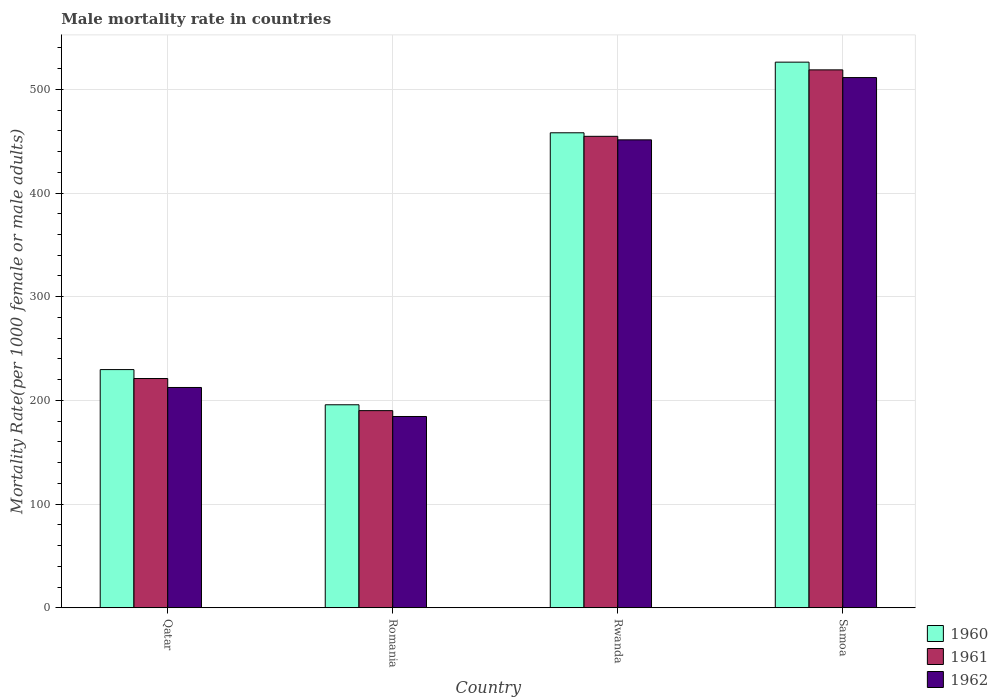How many different coloured bars are there?
Provide a short and direct response. 3. How many groups of bars are there?
Provide a short and direct response. 4. Are the number of bars per tick equal to the number of legend labels?
Provide a short and direct response. Yes. What is the label of the 1st group of bars from the left?
Give a very brief answer. Qatar. In how many cases, is the number of bars for a given country not equal to the number of legend labels?
Make the answer very short. 0. What is the male mortality rate in 1962 in Romania?
Your answer should be compact. 184.47. Across all countries, what is the maximum male mortality rate in 1961?
Offer a terse response. 518.79. Across all countries, what is the minimum male mortality rate in 1960?
Provide a short and direct response. 195.77. In which country was the male mortality rate in 1961 maximum?
Provide a succinct answer. Samoa. In which country was the male mortality rate in 1962 minimum?
Your response must be concise. Romania. What is the total male mortality rate in 1960 in the graph?
Ensure brevity in your answer.  1409.79. What is the difference between the male mortality rate in 1961 in Qatar and that in Romania?
Provide a succinct answer. 30.97. What is the difference between the male mortality rate in 1960 in Qatar and the male mortality rate in 1962 in Romania?
Your answer should be compact. 45.24. What is the average male mortality rate in 1960 per country?
Provide a succinct answer. 352.45. What is the difference between the male mortality rate of/in 1960 and male mortality rate of/in 1961 in Qatar?
Provide a succinct answer. 8.62. In how many countries, is the male mortality rate in 1960 greater than 280?
Ensure brevity in your answer.  2. What is the ratio of the male mortality rate in 1961 in Rwanda to that in Samoa?
Ensure brevity in your answer.  0.88. Is the male mortality rate in 1960 in Qatar less than that in Samoa?
Your answer should be very brief. Yes. What is the difference between the highest and the second highest male mortality rate in 1961?
Offer a very short reply. -233.61. What is the difference between the highest and the lowest male mortality rate in 1962?
Provide a succinct answer. 326.88. In how many countries, is the male mortality rate in 1962 greater than the average male mortality rate in 1962 taken over all countries?
Your response must be concise. 2. Is the sum of the male mortality rate in 1960 in Rwanda and Samoa greater than the maximum male mortality rate in 1962 across all countries?
Your response must be concise. Yes. What does the 2nd bar from the left in Samoa represents?
Provide a short and direct response. 1961. What does the 2nd bar from the right in Rwanda represents?
Ensure brevity in your answer.  1961. Is it the case that in every country, the sum of the male mortality rate in 1961 and male mortality rate in 1962 is greater than the male mortality rate in 1960?
Offer a very short reply. Yes. How many countries are there in the graph?
Offer a very short reply. 4. What is the difference between two consecutive major ticks on the Y-axis?
Keep it short and to the point. 100. Are the values on the major ticks of Y-axis written in scientific E-notation?
Make the answer very short. No. Where does the legend appear in the graph?
Offer a terse response. Bottom right. How many legend labels are there?
Give a very brief answer. 3. How are the legend labels stacked?
Keep it short and to the point. Vertical. What is the title of the graph?
Your answer should be very brief. Male mortality rate in countries. Does "1976" appear as one of the legend labels in the graph?
Make the answer very short. No. What is the label or title of the X-axis?
Your response must be concise. Country. What is the label or title of the Y-axis?
Provide a short and direct response. Mortality Rate(per 1000 female or male adults). What is the Mortality Rate(per 1000 female or male adults) of 1960 in Qatar?
Make the answer very short. 229.71. What is the Mortality Rate(per 1000 female or male adults) in 1961 in Qatar?
Give a very brief answer. 221.08. What is the Mortality Rate(per 1000 female or male adults) of 1962 in Qatar?
Offer a terse response. 212.46. What is the Mortality Rate(per 1000 female or male adults) in 1960 in Romania?
Give a very brief answer. 195.77. What is the Mortality Rate(per 1000 female or male adults) in 1961 in Romania?
Offer a very short reply. 190.12. What is the Mortality Rate(per 1000 female or male adults) in 1962 in Romania?
Your answer should be compact. 184.47. What is the Mortality Rate(per 1000 female or male adults) in 1960 in Rwanda?
Keep it short and to the point. 458.1. What is the Mortality Rate(per 1000 female or male adults) of 1961 in Rwanda?
Offer a terse response. 454.69. What is the Mortality Rate(per 1000 female or male adults) of 1962 in Rwanda?
Make the answer very short. 451.29. What is the Mortality Rate(per 1000 female or male adults) of 1960 in Samoa?
Offer a terse response. 526.23. What is the Mortality Rate(per 1000 female or male adults) of 1961 in Samoa?
Ensure brevity in your answer.  518.79. What is the Mortality Rate(per 1000 female or male adults) of 1962 in Samoa?
Provide a short and direct response. 511.35. Across all countries, what is the maximum Mortality Rate(per 1000 female or male adults) in 1960?
Keep it short and to the point. 526.23. Across all countries, what is the maximum Mortality Rate(per 1000 female or male adults) in 1961?
Offer a very short reply. 518.79. Across all countries, what is the maximum Mortality Rate(per 1000 female or male adults) in 1962?
Your response must be concise. 511.35. Across all countries, what is the minimum Mortality Rate(per 1000 female or male adults) of 1960?
Offer a very short reply. 195.77. Across all countries, what is the minimum Mortality Rate(per 1000 female or male adults) of 1961?
Offer a terse response. 190.12. Across all countries, what is the minimum Mortality Rate(per 1000 female or male adults) in 1962?
Offer a very short reply. 184.47. What is the total Mortality Rate(per 1000 female or male adults) in 1960 in the graph?
Offer a very short reply. 1409.79. What is the total Mortality Rate(per 1000 female or male adults) in 1961 in the graph?
Keep it short and to the point. 1384.68. What is the total Mortality Rate(per 1000 female or male adults) of 1962 in the graph?
Your answer should be very brief. 1359.57. What is the difference between the Mortality Rate(per 1000 female or male adults) of 1960 in Qatar and that in Romania?
Provide a short and direct response. 33.94. What is the difference between the Mortality Rate(per 1000 female or male adults) of 1961 in Qatar and that in Romania?
Ensure brevity in your answer.  30.97. What is the difference between the Mortality Rate(per 1000 female or male adults) of 1962 in Qatar and that in Romania?
Your response must be concise. 27.99. What is the difference between the Mortality Rate(per 1000 female or male adults) in 1960 in Qatar and that in Rwanda?
Make the answer very short. -228.39. What is the difference between the Mortality Rate(per 1000 female or male adults) in 1961 in Qatar and that in Rwanda?
Your answer should be very brief. -233.61. What is the difference between the Mortality Rate(per 1000 female or male adults) of 1962 in Qatar and that in Rwanda?
Ensure brevity in your answer.  -238.83. What is the difference between the Mortality Rate(per 1000 female or male adults) of 1960 in Qatar and that in Samoa?
Offer a very short reply. -296.52. What is the difference between the Mortality Rate(per 1000 female or male adults) of 1961 in Qatar and that in Samoa?
Your answer should be compact. -297.71. What is the difference between the Mortality Rate(per 1000 female or male adults) of 1962 in Qatar and that in Samoa?
Your answer should be compact. -298.89. What is the difference between the Mortality Rate(per 1000 female or male adults) of 1960 in Romania and that in Rwanda?
Make the answer very short. -262.33. What is the difference between the Mortality Rate(per 1000 female or male adults) of 1961 in Romania and that in Rwanda?
Provide a short and direct response. -264.57. What is the difference between the Mortality Rate(per 1000 female or male adults) in 1962 in Romania and that in Rwanda?
Your answer should be very brief. -266.82. What is the difference between the Mortality Rate(per 1000 female or male adults) of 1960 in Romania and that in Samoa?
Your response must be concise. -330.46. What is the difference between the Mortality Rate(per 1000 female or male adults) of 1961 in Romania and that in Samoa?
Make the answer very short. -328.67. What is the difference between the Mortality Rate(per 1000 female or male adults) of 1962 in Romania and that in Samoa?
Keep it short and to the point. -326.88. What is the difference between the Mortality Rate(per 1000 female or male adults) in 1960 in Rwanda and that in Samoa?
Keep it short and to the point. -68.13. What is the difference between the Mortality Rate(per 1000 female or male adults) of 1961 in Rwanda and that in Samoa?
Offer a terse response. -64.1. What is the difference between the Mortality Rate(per 1000 female or male adults) of 1962 in Rwanda and that in Samoa?
Your answer should be very brief. -60.07. What is the difference between the Mortality Rate(per 1000 female or male adults) in 1960 in Qatar and the Mortality Rate(per 1000 female or male adults) in 1961 in Romania?
Provide a short and direct response. 39.59. What is the difference between the Mortality Rate(per 1000 female or male adults) of 1960 in Qatar and the Mortality Rate(per 1000 female or male adults) of 1962 in Romania?
Your answer should be very brief. 45.24. What is the difference between the Mortality Rate(per 1000 female or male adults) in 1961 in Qatar and the Mortality Rate(per 1000 female or male adults) in 1962 in Romania?
Give a very brief answer. 36.61. What is the difference between the Mortality Rate(per 1000 female or male adults) in 1960 in Qatar and the Mortality Rate(per 1000 female or male adults) in 1961 in Rwanda?
Provide a succinct answer. -224.99. What is the difference between the Mortality Rate(per 1000 female or male adults) of 1960 in Qatar and the Mortality Rate(per 1000 female or male adults) of 1962 in Rwanda?
Your response must be concise. -221.58. What is the difference between the Mortality Rate(per 1000 female or male adults) of 1961 in Qatar and the Mortality Rate(per 1000 female or male adults) of 1962 in Rwanda?
Make the answer very short. -230.21. What is the difference between the Mortality Rate(per 1000 female or male adults) in 1960 in Qatar and the Mortality Rate(per 1000 female or male adults) in 1961 in Samoa?
Give a very brief answer. -289.08. What is the difference between the Mortality Rate(per 1000 female or male adults) in 1960 in Qatar and the Mortality Rate(per 1000 female or male adults) in 1962 in Samoa?
Provide a short and direct response. -281.65. What is the difference between the Mortality Rate(per 1000 female or male adults) in 1961 in Qatar and the Mortality Rate(per 1000 female or male adults) in 1962 in Samoa?
Provide a succinct answer. -290.27. What is the difference between the Mortality Rate(per 1000 female or male adults) in 1960 in Romania and the Mortality Rate(per 1000 female or male adults) in 1961 in Rwanda?
Provide a succinct answer. -258.93. What is the difference between the Mortality Rate(per 1000 female or male adults) in 1960 in Romania and the Mortality Rate(per 1000 female or male adults) in 1962 in Rwanda?
Your answer should be very brief. -255.52. What is the difference between the Mortality Rate(per 1000 female or male adults) of 1961 in Romania and the Mortality Rate(per 1000 female or male adults) of 1962 in Rwanda?
Make the answer very short. -261.17. What is the difference between the Mortality Rate(per 1000 female or male adults) of 1960 in Romania and the Mortality Rate(per 1000 female or male adults) of 1961 in Samoa?
Make the answer very short. -323.02. What is the difference between the Mortality Rate(per 1000 female or male adults) of 1960 in Romania and the Mortality Rate(per 1000 female or male adults) of 1962 in Samoa?
Make the answer very short. -315.59. What is the difference between the Mortality Rate(per 1000 female or male adults) in 1961 in Romania and the Mortality Rate(per 1000 female or male adults) in 1962 in Samoa?
Your answer should be compact. -321.24. What is the difference between the Mortality Rate(per 1000 female or male adults) in 1960 in Rwanda and the Mortality Rate(per 1000 female or male adults) in 1961 in Samoa?
Offer a very short reply. -60.69. What is the difference between the Mortality Rate(per 1000 female or male adults) in 1960 in Rwanda and the Mortality Rate(per 1000 female or male adults) in 1962 in Samoa?
Your answer should be very brief. -53.26. What is the difference between the Mortality Rate(per 1000 female or male adults) of 1961 in Rwanda and the Mortality Rate(per 1000 female or male adults) of 1962 in Samoa?
Your response must be concise. -56.66. What is the average Mortality Rate(per 1000 female or male adults) in 1960 per country?
Provide a succinct answer. 352.45. What is the average Mortality Rate(per 1000 female or male adults) of 1961 per country?
Your answer should be very brief. 346.17. What is the average Mortality Rate(per 1000 female or male adults) in 1962 per country?
Offer a terse response. 339.89. What is the difference between the Mortality Rate(per 1000 female or male adults) in 1960 and Mortality Rate(per 1000 female or male adults) in 1961 in Qatar?
Offer a very short reply. 8.62. What is the difference between the Mortality Rate(per 1000 female or male adults) in 1960 and Mortality Rate(per 1000 female or male adults) in 1962 in Qatar?
Keep it short and to the point. 17.25. What is the difference between the Mortality Rate(per 1000 female or male adults) of 1961 and Mortality Rate(per 1000 female or male adults) of 1962 in Qatar?
Offer a terse response. 8.62. What is the difference between the Mortality Rate(per 1000 female or male adults) of 1960 and Mortality Rate(per 1000 female or male adults) of 1961 in Romania?
Your answer should be very brief. 5.65. What is the difference between the Mortality Rate(per 1000 female or male adults) of 1960 and Mortality Rate(per 1000 female or male adults) of 1962 in Romania?
Your answer should be compact. 11.3. What is the difference between the Mortality Rate(per 1000 female or male adults) of 1961 and Mortality Rate(per 1000 female or male adults) of 1962 in Romania?
Offer a terse response. 5.65. What is the difference between the Mortality Rate(per 1000 female or male adults) of 1960 and Mortality Rate(per 1000 female or male adults) of 1961 in Rwanda?
Provide a succinct answer. 3.4. What is the difference between the Mortality Rate(per 1000 female or male adults) of 1960 and Mortality Rate(per 1000 female or male adults) of 1962 in Rwanda?
Make the answer very short. 6.81. What is the difference between the Mortality Rate(per 1000 female or male adults) in 1961 and Mortality Rate(per 1000 female or male adults) in 1962 in Rwanda?
Your answer should be very brief. 3.4. What is the difference between the Mortality Rate(per 1000 female or male adults) in 1960 and Mortality Rate(per 1000 female or male adults) in 1961 in Samoa?
Offer a very short reply. 7.44. What is the difference between the Mortality Rate(per 1000 female or male adults) in 1960 and Mortality Rate(per 1000 female or male adults) in 1962 in Samoa?
Your response must be concise. 14.87. What is the difference between the Mortality Rate(per 1000 female or male adults) in 1961 and Mortality Rate(per 1000 female or male adults) in 1962 in Samoa?
Offer a terse response. 7.43. What is the ratio of the Mortality Rate(per 1000 female or male adults) in 1960 in Qatar to that in Romania?
Give a very brief answer. 1.17. What is the ratio of the Mortality Rate(per 1000 female or male adults) of 1961 in Qatar to that in Romania?
Provide a succinct answer. 1.16. What is the ratio of the Mortality Rate(per 1000 female or male adults) in 1962 in Qatar to that in Romania?
Keep it short and to the point. 1.15. What is the ratio of the Mortality Rate(per 1000 female or male adults) of 1960 in Qatar to that in Rwanda?
Make the answer very short. 0.5. What is the ratio of the Mortality Rate(per 1000 female or male adults) of 1961 in Qatar to that in Rwanda?
Offer a very short reply. 0.49. What is the ratio of the Mortality Rate(per 1000 female or male adults) in 1962 in Qatar to that in Rwanda?
Ensure brevity in your answer.  0.47. What is the ratio of the Mortality Rate(per 1000 female or male adults) of 1960 in Qatar to that in Samoa?
Offer a terse response. 0.44. What is the ratio of the Mortality Rate(per 1000 female or male adults) of 1961 in Qatar to that in Samoa?
Provide a succinct answer. 0.43. What is the ratio of the Mortality Rate(per 1000 female or male adults) in 1962 in Qatar to that in Samoa?
Provide a succinct answer. 0.42. What is the ratio of the Mortality Rate(per 1000 female or male adults) in 1960 in Romania to that in Rwanda?
Ensure brevity in your answer.  0.43. What is the ratio of the Mortality Rate(per 1000 female or male adults) in 1961 in Romania to that in Rwanda?
Provide a succinct answer. 0.42. What is the ratio of the Mortality Rate(per 1000 female or male adults) of 1962 in Romania to that in Rwanda?
Make the answer very short. 0.41. What is the ratio of the Mortality Rate(per 1000 female or male adults) in 1960 in Romania to that in Samoa?
Offer a very short reply. 0.37. What is the ratio of the Mortality Rate(per 1000 female or male adults) in 1961 in Romania to that in Samoa?
Provide a short and direct response. 0.37. What is the ratio of the Mortality Rate(per 1000 female or male adults) of 1962 in Romania to that in Samoa?
Provide a succinct answer. 0.36. What is the ratio of the Mortality Rate(per 1000 female or male adults) in 1960 in Rwanda to that in Samoa?
Your answer should be compact. 0.87. What is the ratio of the Mortality Rate(per 1000 female or male adults) in 1961 in Rwanda to that in Samoa?
Keep it short and to the point. 0.88. What is the ratio of the Mortality Rate(per 1000 female or male adults) in 1962 in Rwanda to that in Samoa?
Your answer should be compact. 0.88. What is the difference between the highest and the second highest Mortality Rate(per 1000 female or male adults) of 1960?
Offer a terse response. 68.13. What is the difference between the highest and the second highest Mortality Rate(per 1000 female or male adults) in 1961?
Give a very brief answer. 64.1. What is the difference between the highest and the second highest Mortality Rate(per 1000 female or male adults) of 1962?
Give a very brief answer. 60.07. What is the difference between the highest and the lowest Mortality Rate(per 1000 female or male adults) of 1960?
Offer a very short reply. 330.46. What is the difference between the highest and the lowest Mortality Rate(per 1000 female or male adults) in 1961?
Provide a succinct answer. 328.67. What is the difference between the highest and the lowest Mortality Rate(per 1000 female or male adults) in 1962?
Provide a short and direct response. 326.88. 